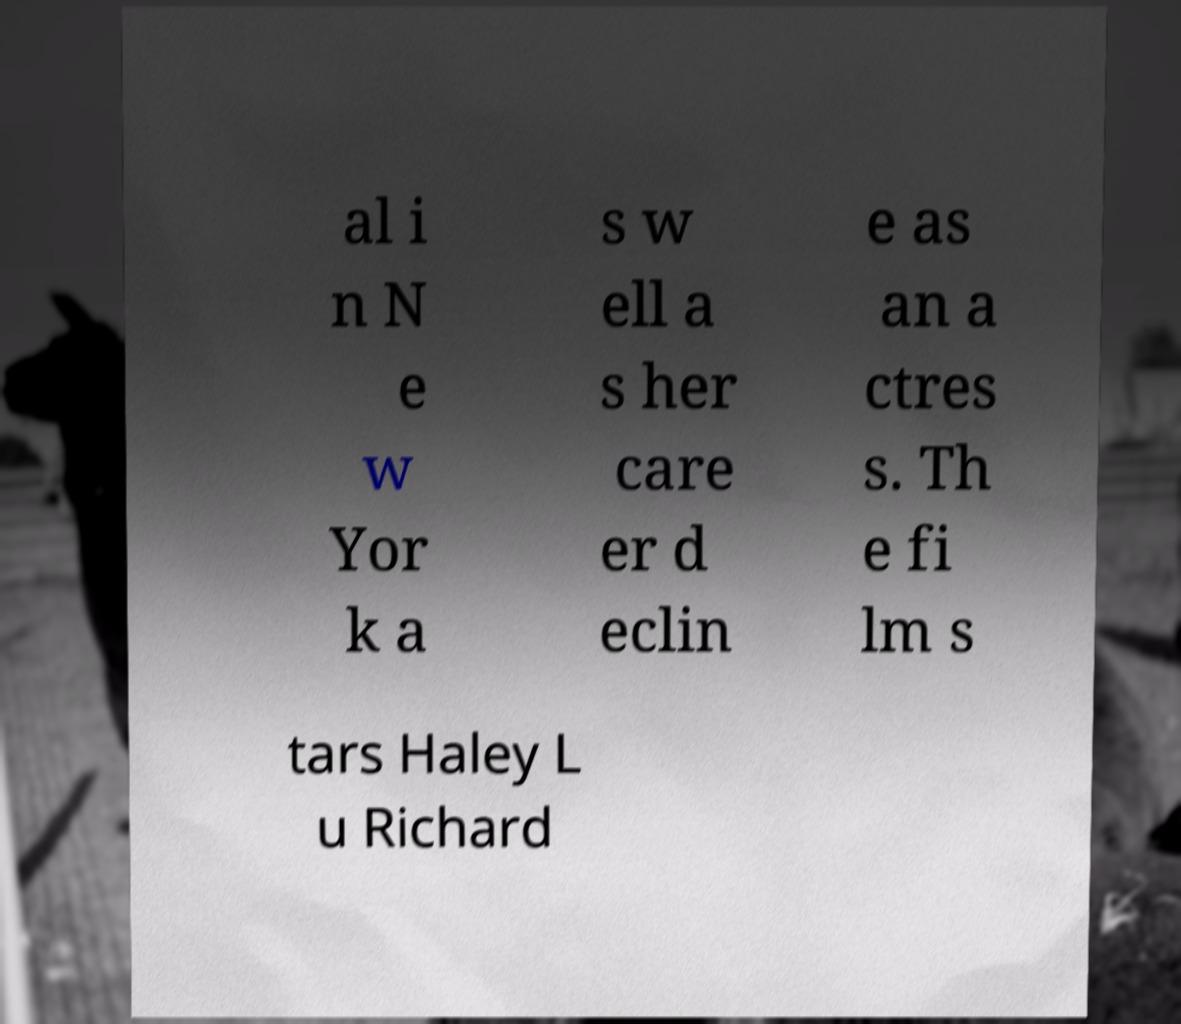I need the written content from this picture converted into text. Can you do that? al i n N e w Yor k a s w ell a s her care er d eclin e as an a ctres s. Th e fi lm s tars Haley L u Richard 